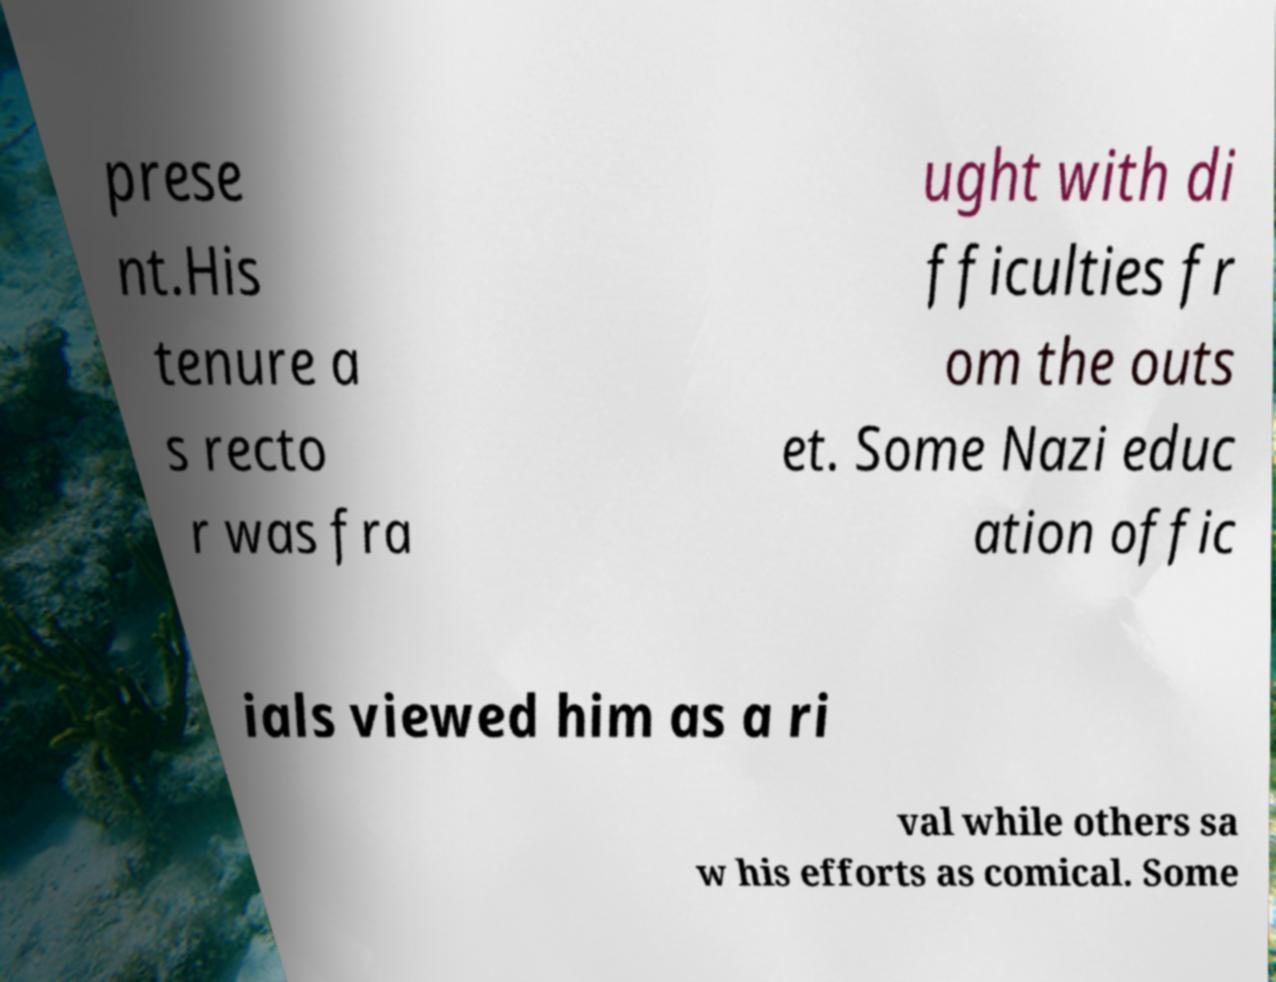I need the written content from this picture converted into text. Can you do that? prese nt.His tenure a s recto r was fra ught with di fficulties fr om the outs et. Some Nazi educ ation offic ials viewed him as a ri val while others sa w his efforts as comical. Some 